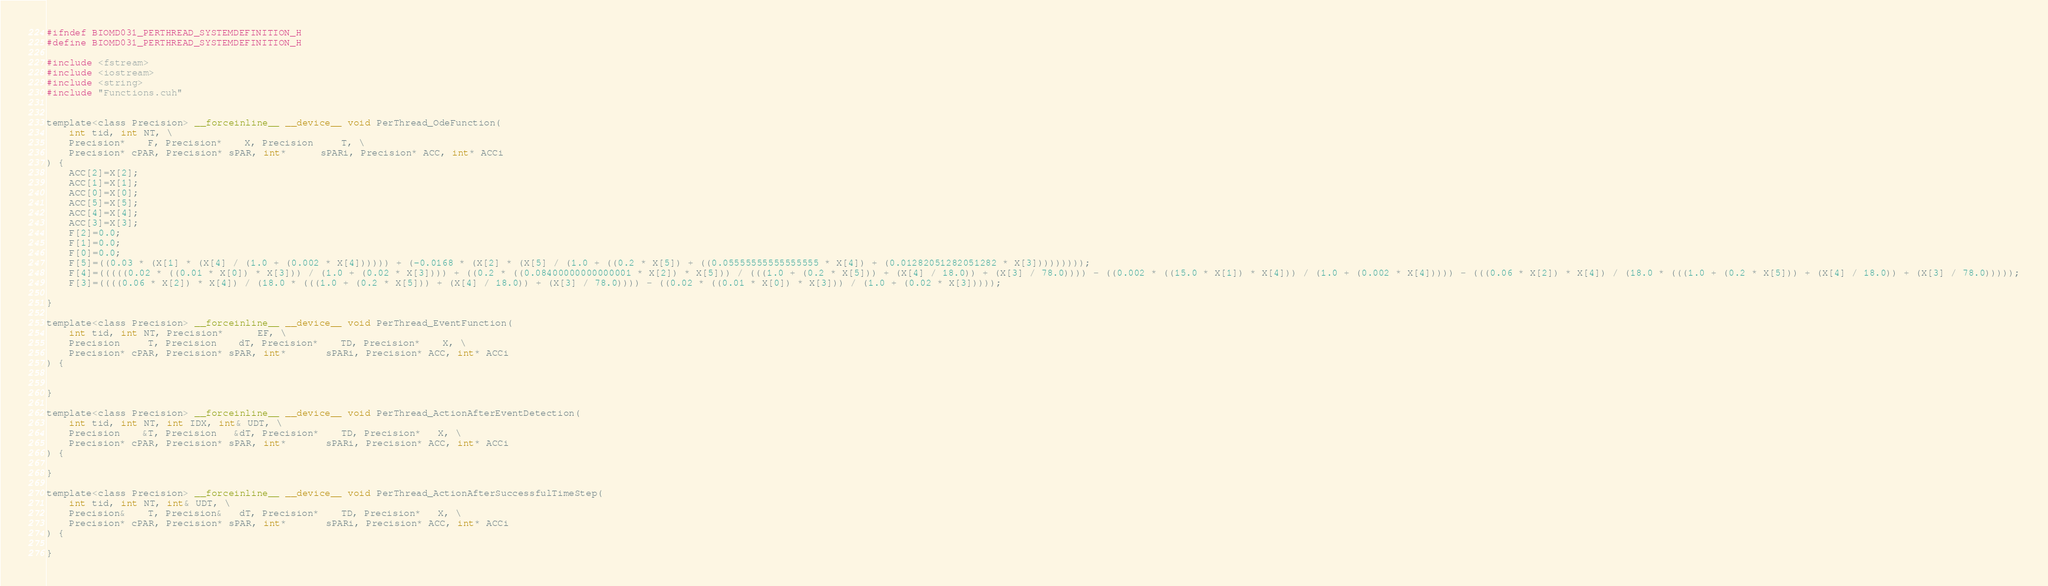<code> <loc_0><loc_0><loc_500><loc_500><_Cuda_>
#ifndef BIOMD031_PERTHREAD_SYSTEMDEFINITION_H
#define BIOMD031_PERTHREAD_SYSTEMDEFINITION_H

#include <fstream>
#include <iostream>
#include <string>
#include "Functions.cuh"


template<class Precision> __forceinline__ __device__ void PerThread_OdeFunction(
	int tid, int NT, \
	Precision*    F, Precision*    X, Precision     T, \
	Precision* cPAR, Precision* sPAR, int*      sPARi, Precision* ACC, int* ACCi  		
) {
    ACC[2]=X[2];
    ACC[1]=X[1];
    ACC[0]=X[0];
    ACC[5]=X[5];
    ACC[4]=X[4];
    ACC[3]=X[3];
    F[2]=0.0;
    F[1]=0.0;
    F[0]=0.0;
    F[5]=((0.03 * (X[1] * (X[4] / (1.0 + (0.002 * X[4]))))) + (-0.0168 * (X[2] * (X[5] / (1.0 + ((0.2 * X[5]) + ((0.05555555555555555 * X[4]) + (0.01282051282051282 * X[3]))))))));
    F[4]=(((((0.02 * ((0.01 * X[0]) * X[3])) / (1.0 + (0.02 * X[3]))) + ((0.2 * ((0.08400000000000001 * X[2]) * X[5])) / (((1.0 + (0.2 * X[5])) + (X[4] / 18.0)) + (X[3] / 78.0)))) - ((0.002 * ((15.0 * X[1]) * X[4])) / (1.0 + (0.002 * X[4])))) - (((0.06 * X[2]) * X[4]) / (18.0 * (((1.0 + (0.2 * X[5])) + (X[4] / 18.0)) + (X[3] / 78.0)))));
    F[3]=((((0.06 * X[2]) * X[4]) / (18.0 * (((1.0 + (0.2 * X[5])) + (X[4] / 18.0)) + (X[3] / 78.0)))) - ((0.02 * ((0.01 * X[0]) * X[3])) / (1.0 + (0.02 * X[3]))));

}

template<class Precision> __forceinline__ __device__ void PerThread_EventFunction(
	int tid, int NT, Precision*	  EF, \
	Precision     T, Precision    dT, Precision*    TD, Precision*	X, \
	Precision* cPAR, Precision* sPAR, int*       sPARi, Precision* ACC, int* ACCi  		
) {
    

}

template<class Precision> __forceinline__ __device__ void PerThread_ActionAfterEventDetection(
    int tid, int NT, int IDX, int& UDT, \
    Precision    &T, Precision   &dT, Precision*    TD, Precision*   X, \
    Precision* cPAR, Precision* sPAR, int*       sPARi, Precision* ACC, int* ACCi
) {
    
}

template<class Precision> __forceinline__ __device__ void PerThread_ActionAfterSuccessfulTimeStep(
    int tid, int NT, int& UDT, \
    Precision&    T, Precision&   dT, Precision*    TD, Precision*   X, \
    Precision* cPAR, Precision* sPAR, int*       sPARi, Precision* ACC, int* ACCi
) {
    
}
</code> 